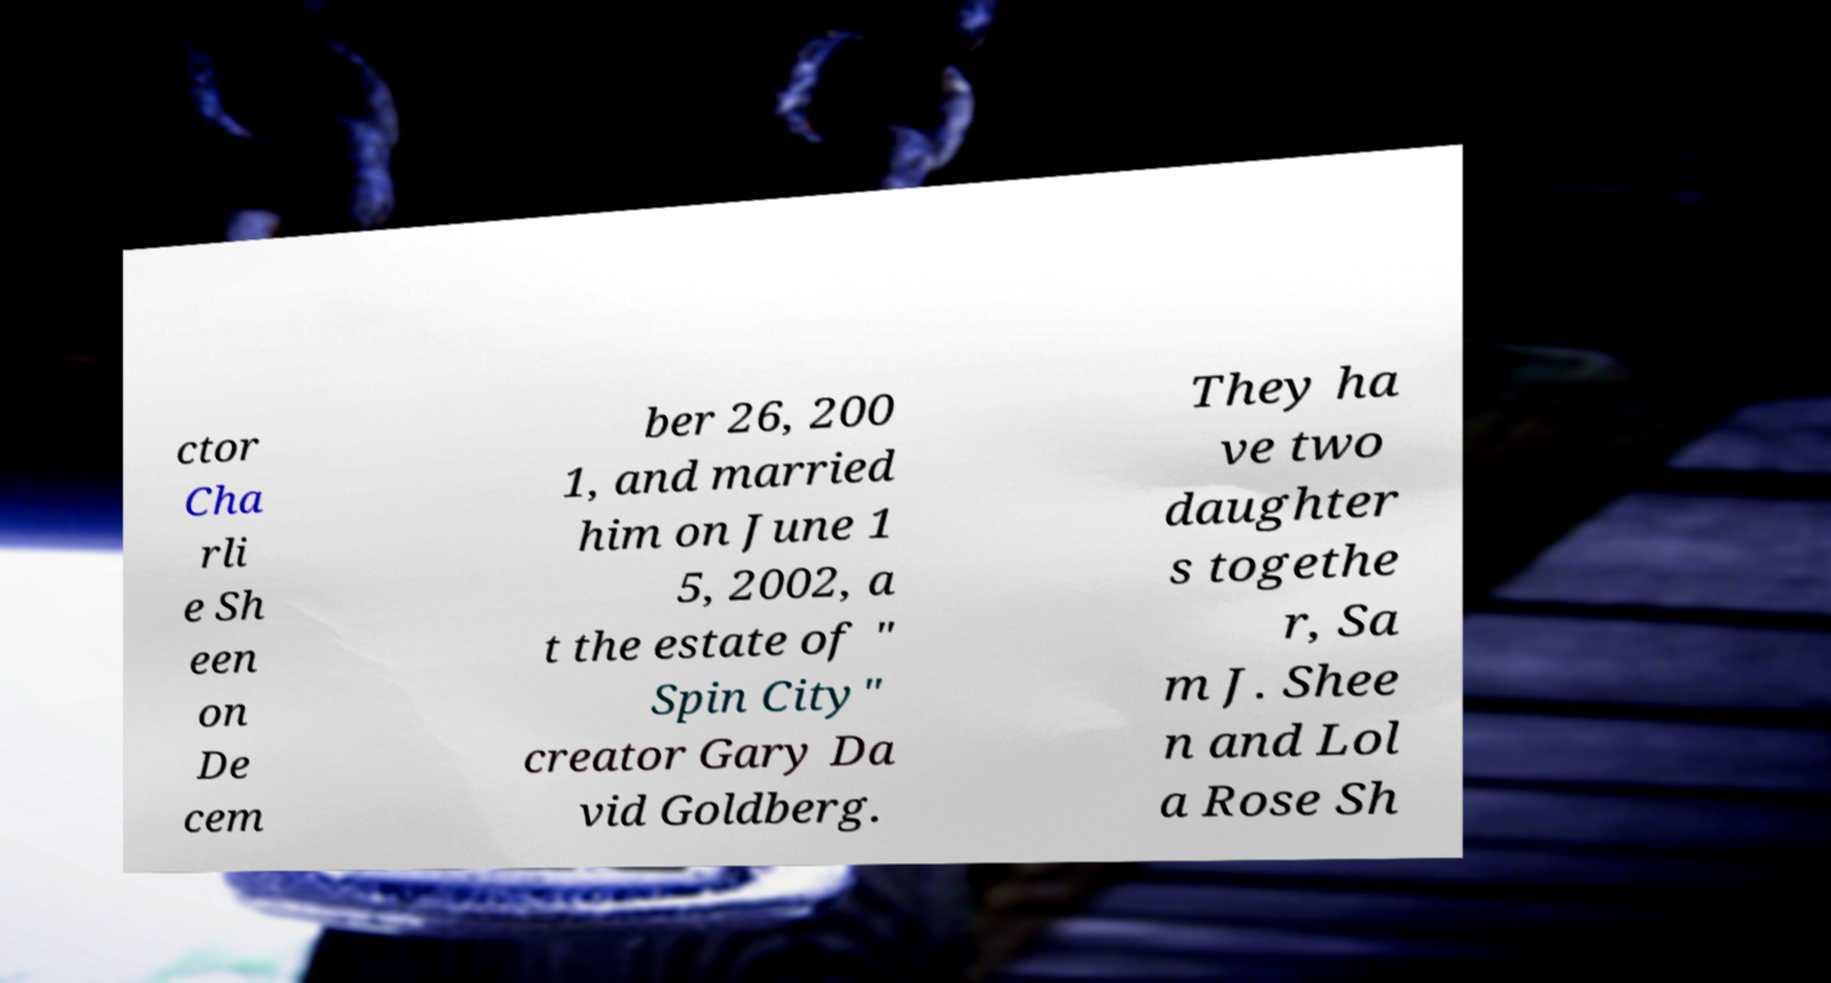Can you read and provide the text displayed in the image?This photo seems to have some interesting text. Can you extract and type it out for me? ctor Cha rli e Sh een on De cem ber 26, 200 1, and married him on June 1 5, 2002, a t the estate of " Spin City" creator Gary Da vid Goldberg. They ha ve two daughter s togethe r, Sa m J. Shee n and Lol a Rose Sh 